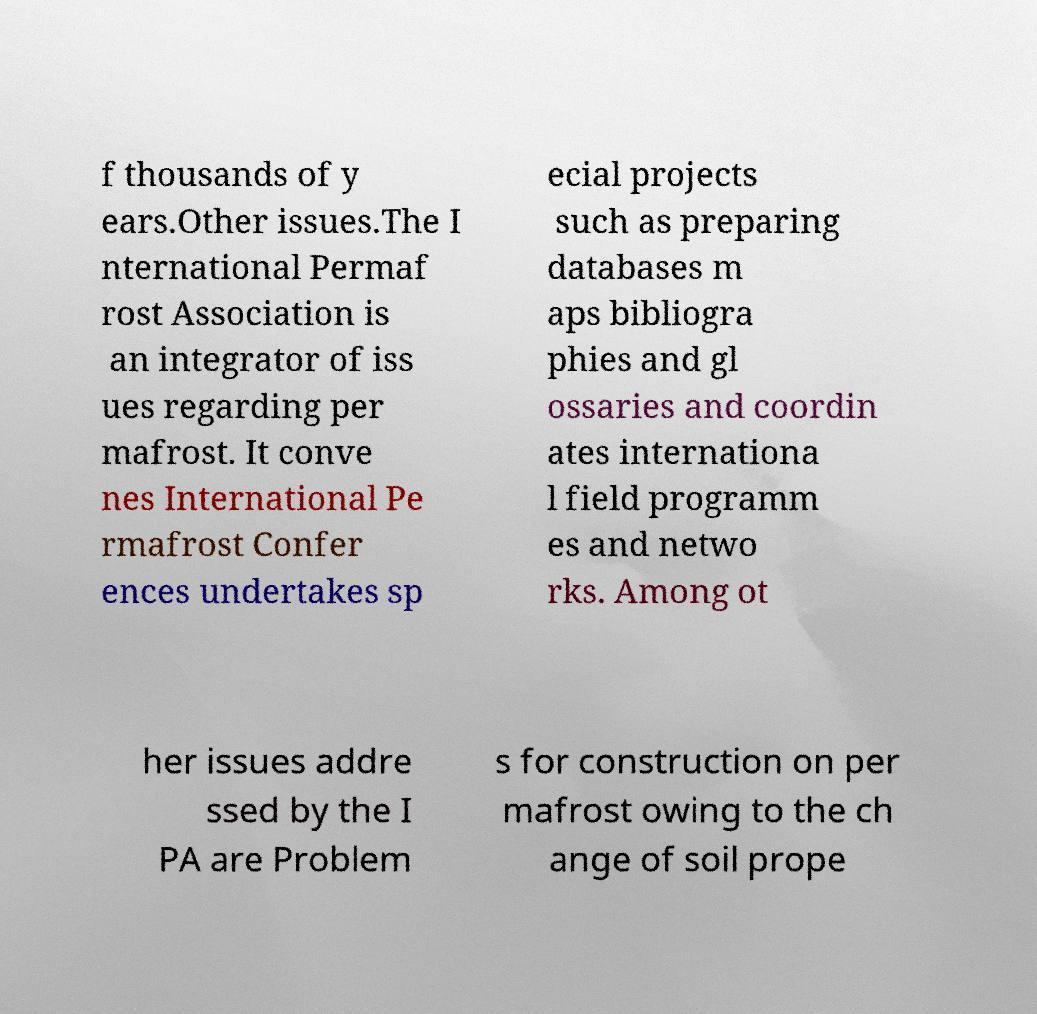Please read and relay the text visible in this image. What does it say? f thousands of y ears.Other issues.The I nternational Permaf rost Association is an integrator of iss ues regarding per mafrost. It conve nes International Pe rmafrost Confer ences undertakes sp ecial projects such as preparing databases m aps bibliogra phies and gl ossaries and coordin ates internationa l field programm es and netwo rks. Among ot her issues addre ssed by the I PA are Problem s for construction on per mafrost owing to the ch ange of soil prope 